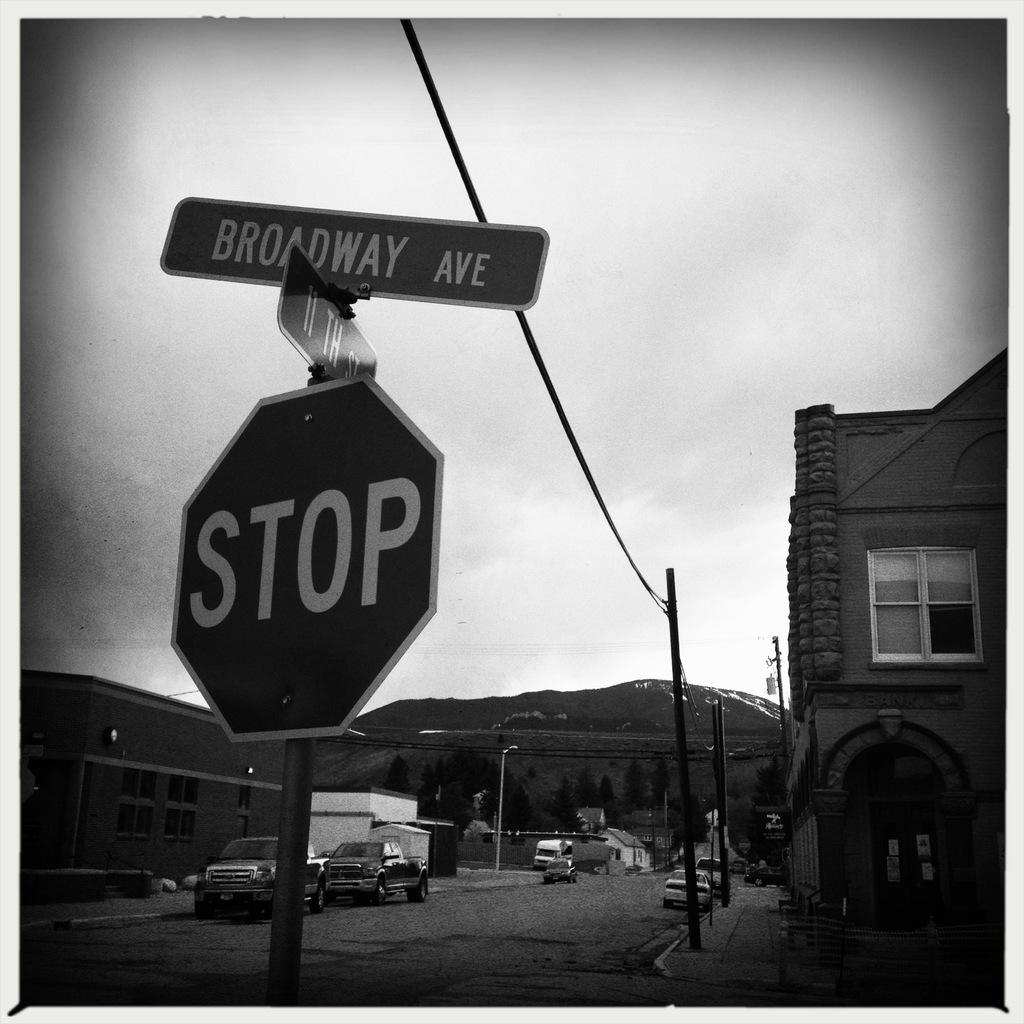<image>
Present a compact description of the photo's key features. a stop sign that is outside in the daytime 